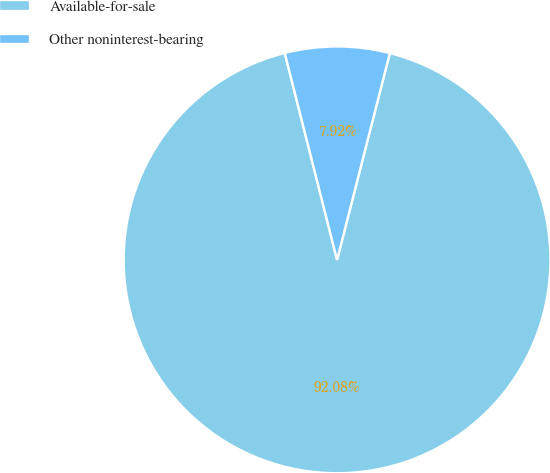Convert chart to OTSL. <chart><loc_0><loc_0><loc_500><loc_500><pie_chart><fcel>Available-for-sale<fcel>Other noninterest-bearing<nl><fcel>92.08%<fcel>7.92%<nl></chart> 